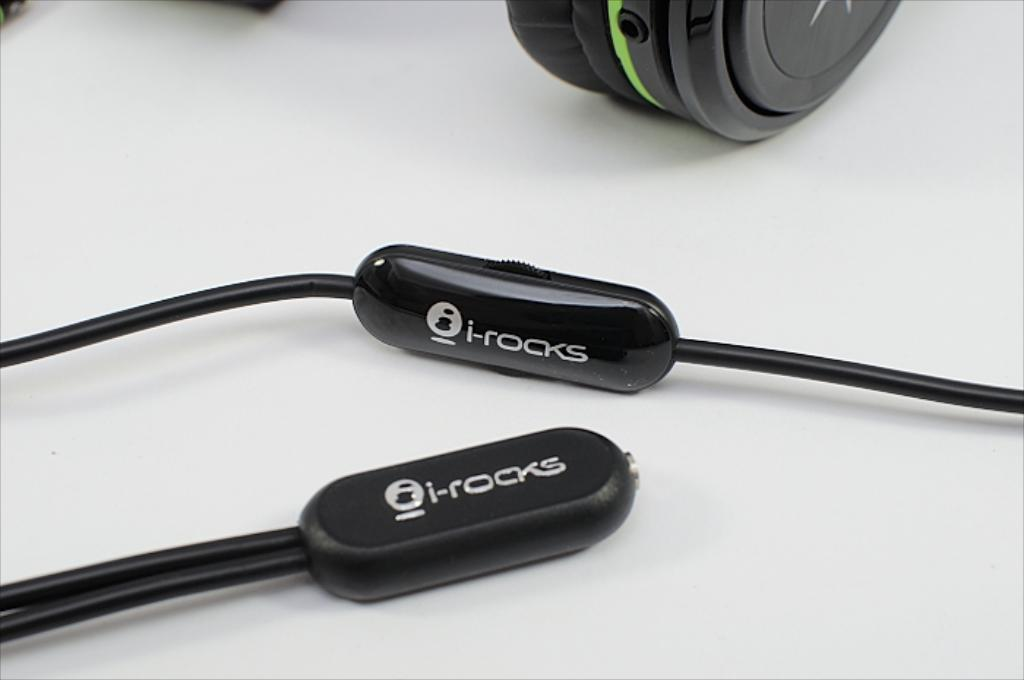<image>
Provide a brief description of the given image. two Irocks wires that are sitting on a white table with another electronic in the background 